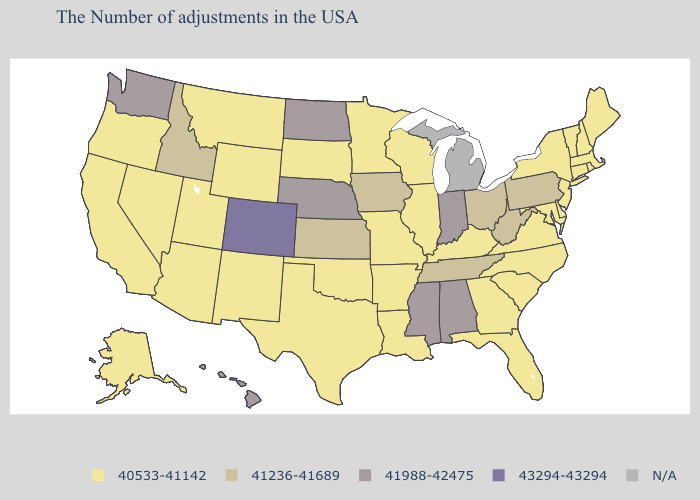Name the states that have a value in the range 43294-43294?
Keep it brief. Colorado. Name the states that have a value in the range 43294-43294?
Concise answer only. Colorado. Name the states that have a value in the range 41236-41689?
Quick response, please. Pennsylvania, West Virginia, Ohio, Tennessee, Iowa, Kansas, Idaho. Name the states that have a value in the range 41236-41689?
Write a very short answer. Pennsylvania, West Virginia, Ohio, Tennessee, Iowa, Kansas, Idaho. Name the states that have a value in the range 40533-41142?
Keep it brief. Maine, Massachusetts, Rhode Island, New Hampshire, Vermont, Connecticut, New York, New Jersey, Delaware, Maryland, Virginia, North Carolina, South Carolina, Florida, Georgia, Kentucky, Wisconsin, Illinois, Louisiana, Missouri, Arkansas, Minnesota, Oklahoma, Texas, South Dakota, Wyoming, New Mexico, Utah, Montana, Arizona, Nevada, California, Oregon, Alaska. Name the states that have a value in the range 43294-43294?
Be succinct. Colorado. Does Virginia have the highest value in the USA?
Keep it brief. No. How many symbols are there in the legend?
Be succinct. 5. Name the states that have a value in the range 43294-43294?
Give a very brief answer. Colorado. What is the value of Illinois?
Quick response, please. 40533-41142. What is the value of Michigan?
Answer briefly. N/A. What is the lowest value in the USA?
Answer briefly. 40533-41142. Does the first symbol in the legend represent the smallest category?
Quick response, please. Yes. What is the lowest value in the USA?
Quick response, please. 40533-41142. 